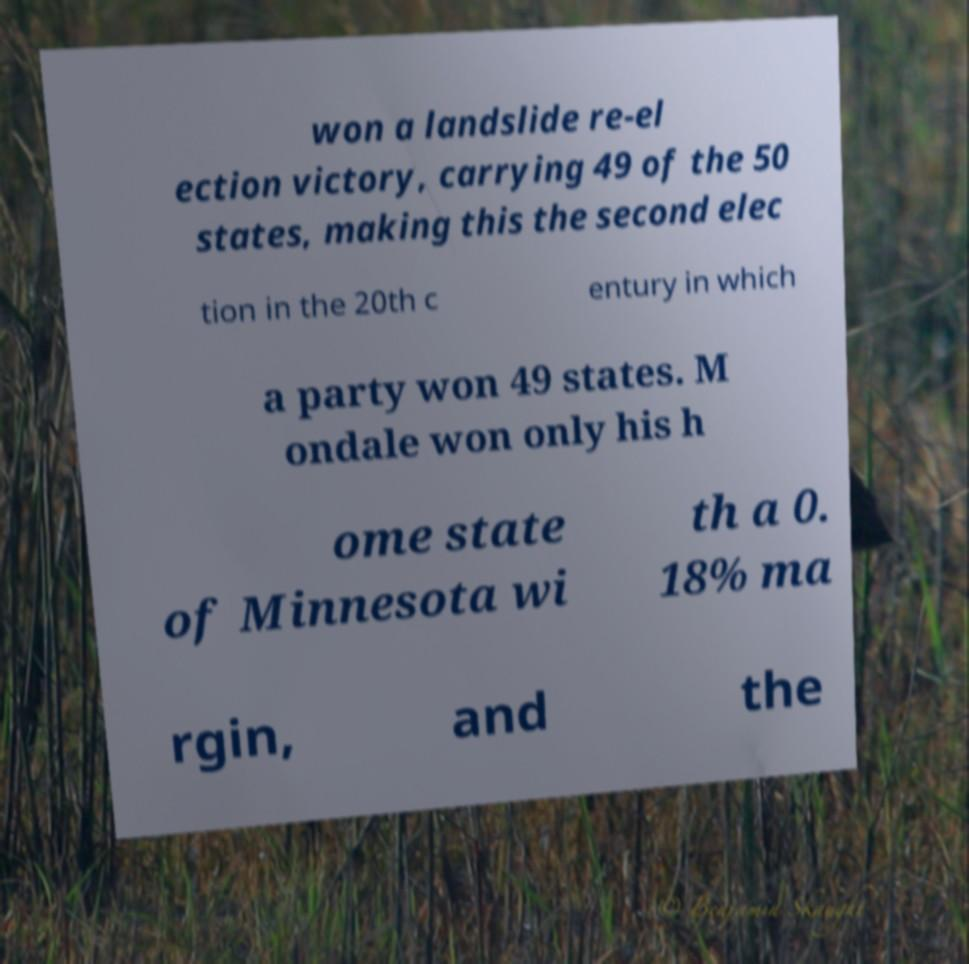Please read and relay the text visible in this image. What does it say? won a landslide re-el ection victory, carrying 49 of the 50 states, making this the second elec tion in the 20th c entury in which a party won 49 states. M ondale won only his h ome state of Minnesota wi th a 0. 18% ma rgin, and the 